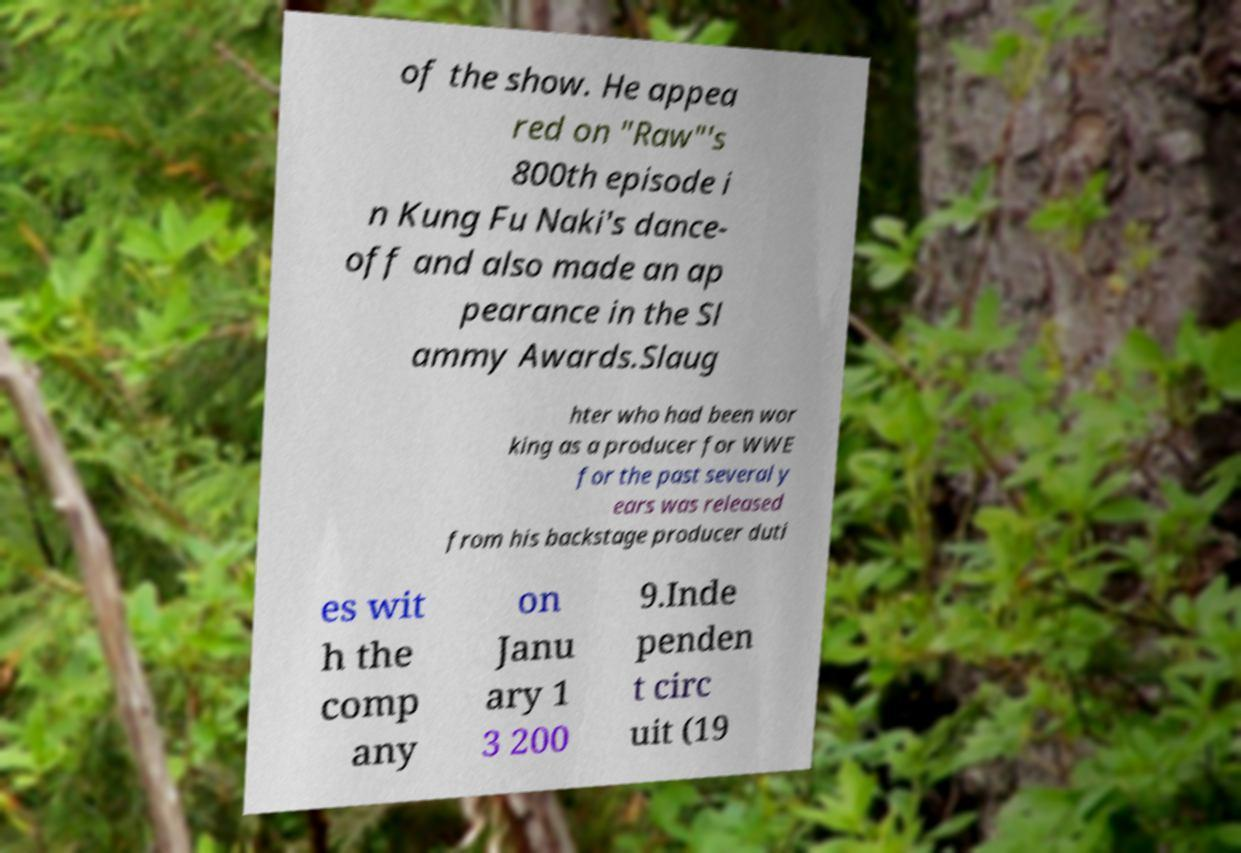Could you assist in decoding the text presented in this image and type it out clearly? of the show. He appea red on "Raw"'s 800th episode i n Kung Fu Naki's dance- off and also made an ap pearance in the Sl ammy Awards.Slaug hter who had been wor king as a producer for WWE for the past several y ears was released from his backstage producer duti es wit h the comp any on Janu ary 1 3 200 9.Inde penden t circ uit (19 